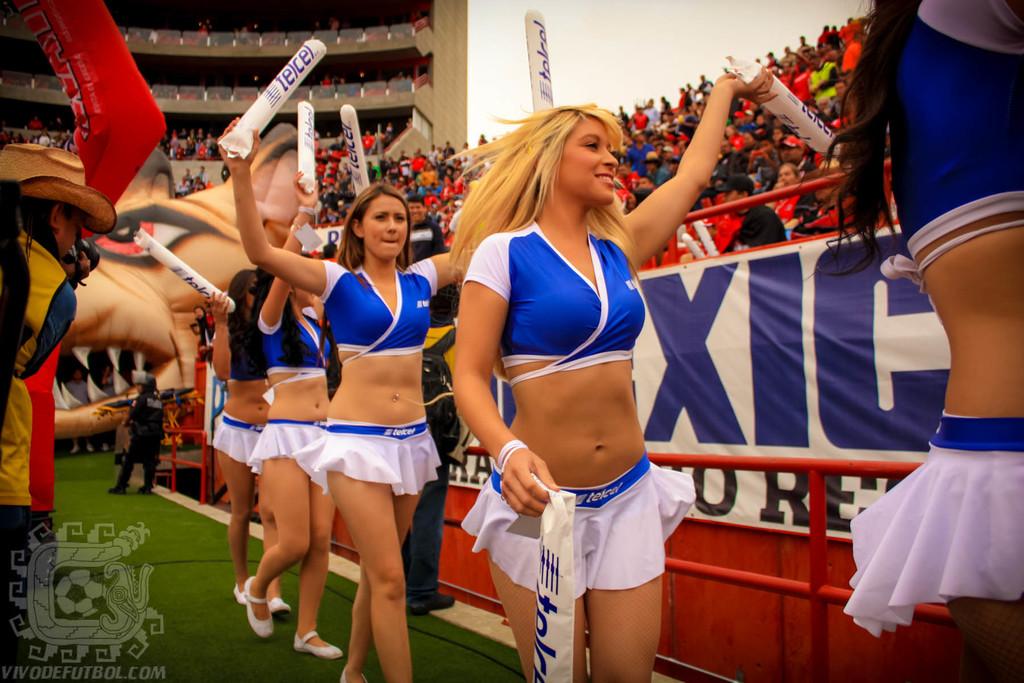What sponsor is on the wands the girls are waving?
Keep it short and to the point. Telcel. 